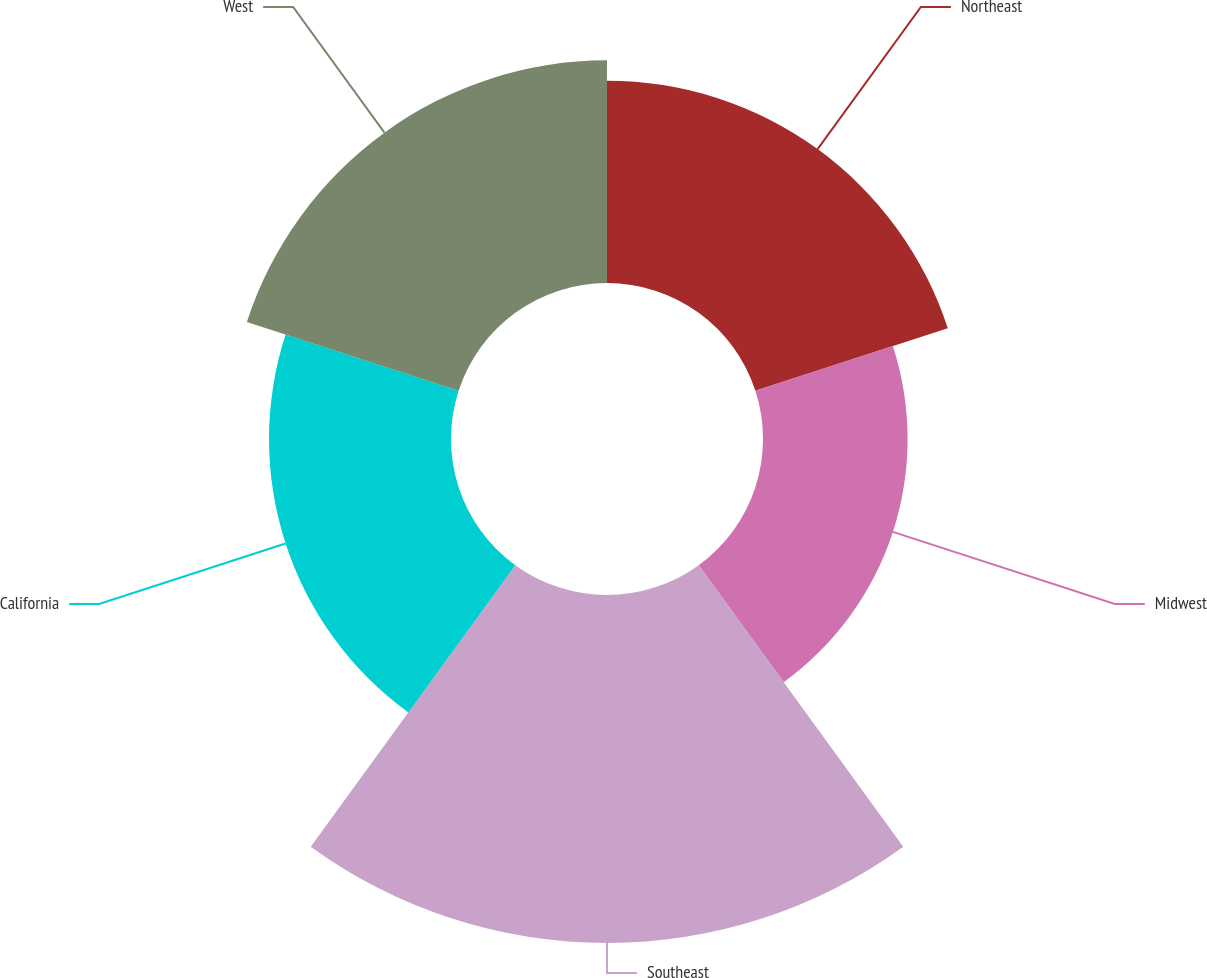<chart> <loc_0><loc_0><loc_500><loc_500><pie_chart><fcel>Northeast<fcel>Midwest<fcel>Southeast<fcel>California<fcel>West<nl><fcel>18.4%<fcel>13.15%<fcel>31.65%<fcel>16.55%<fcel>20.25%<nl></chart> 